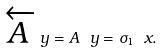<formula> <loc_0><loc_0><loc_500><loc_500>\overleftarrow { A } \ y = A \ y = \sigma _ { 1 } \ x .</formula> 